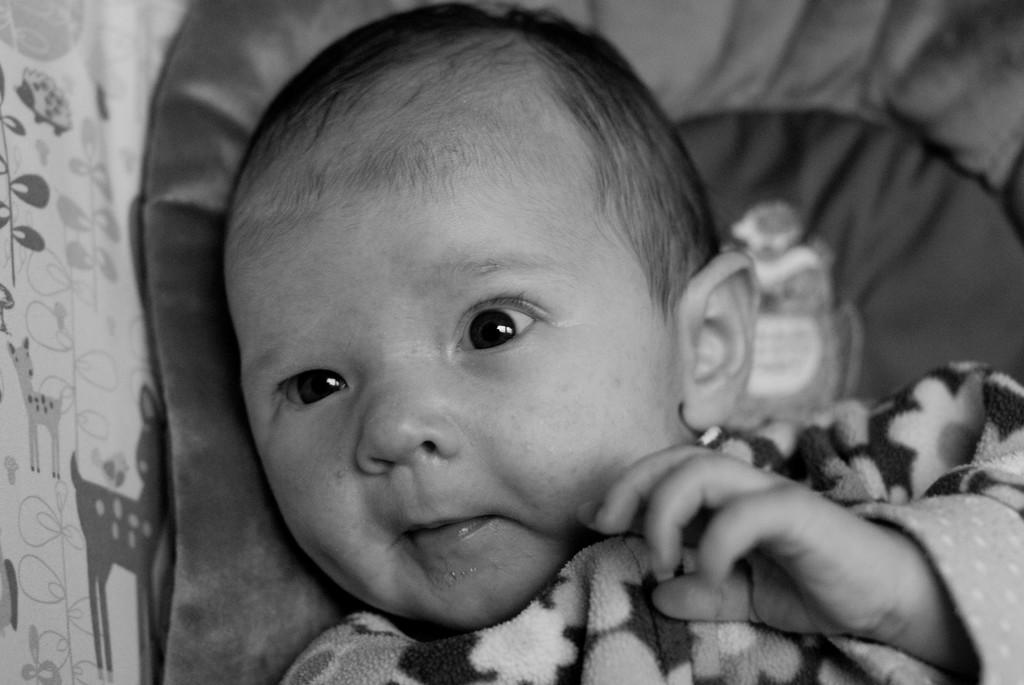What is the main subject of the image? The main subject of the image is a baby lying on the bed. What can be seen on the cloth in the image? There are animal pictures on the cloth in the image. How is the image presented in terms of color? The image is in black and white mode. What type of poison is the baby holding in the image? There is no poison present in the image; the baby is lying on the bed with animal pictures on the cloth. Can you tell me the name of the judge in the image? There is no judge present in the image; it features a baby lying on the bed with animal pictures on the cloth. 